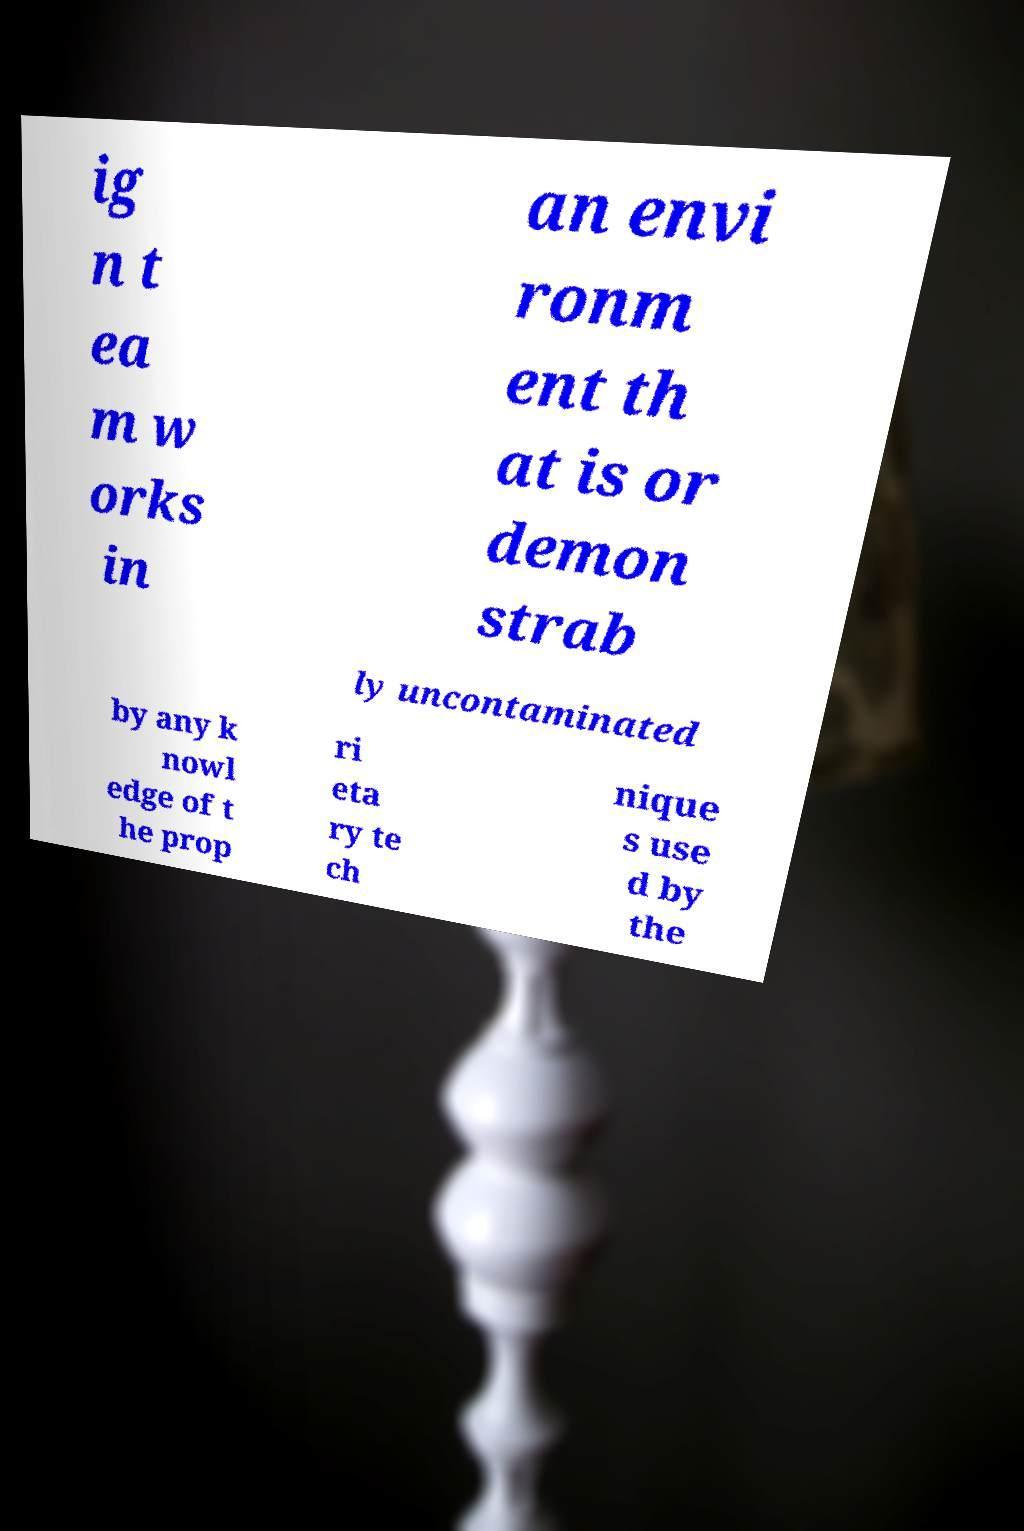Can you read and provide the text displayed in the image?This photo seems to have some interesting text. Can you extract and type it out for me? ig n t ea m w orks in an envi ronm ent th at is or demon strab ly uncontaminated by any k nowl edge of t he prop ri eta ry te ch nique s use d by the 